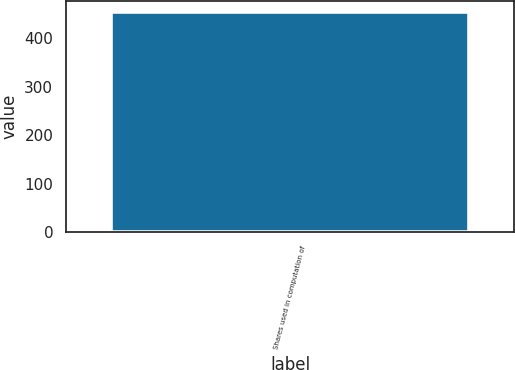Convert chart. <chart><loc_0><loc_0><loc_500><loc_500><bar_chart><fcel>Shares used in computation of<nl><fcel>453.1<nl></chart> 